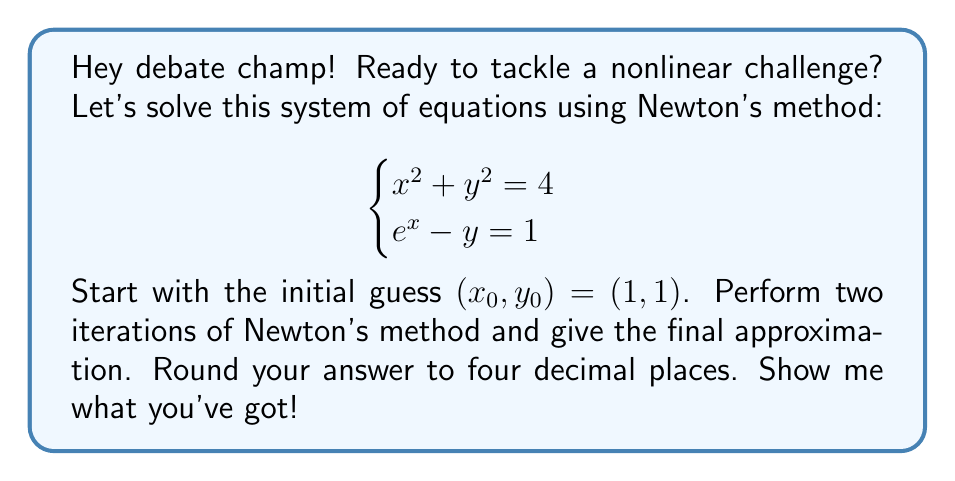Give your solution to this math problem. Alright, let's break this down step-by-step:

1) First, we need to define our functions:
   $f_1(x,y) = x^2 + y^2 - 4$
   $f_2(x,y) = e^x - y - 1$

2) Now, we need to calculate the Jacobian matrix:
   $$J = \begin{bmatrix}
   \frac{\partial f_1}{\partial x} & \frac{\partial f_1}{\partial y} \\
   \frac{\partial f_2}{\partial x} & \frac{\partial f_2}{\partial y}
   \end{bmatrix} = \begin{bmatrix}
   2x & 2y \\
   e^x & -1
   \end{bmatrix}$$

3) Newton's method for systems of equations is given by:
   $$\begin{bmatrix} x_{n+1} \\ y_{n+1} \end{bmatrix} = \begin{bmatrix} x_n \\ y_n \end{bmatrix} - J^{-1}(x_n, y_n) \begin{bmatrix} f_1(x_n, y_n) \\ f_2(x_n, y_n) \end{bmatrix}$$

4) For the first iteration $(n=0)$:
   $x_0 = 1, y_0 = 1$
   
   $J(1,1) = \begin{bmatrix} 2 & 2 \\ e & -1 \end{bmatrix}$
   
   $J^{-1}(1,1) = \frac{1}{-2-2e} \begin{bmatrix} -1 & -2 \\ -e & -2 \end{bmatrix}$
   
   $\begin{bmatrix} f_1(1,1) \\ f_2(1,1) \end{bmatrix} = \begin{bmatrix} -2 \\ e-2 \end{bmatrix}$

   $$\begin{bmatrix} x_1 \\ y_1 \end{bmatrix} = \begin{bmatrix} 1 \\ 1 \end{bmatrix} - \frac{1}{-2-2e} \begin{bmatrix} -1 & -2 \\ -e & -2 \end{bmatrix} \begin{bmatrix} -2 \\ e-2 \end{bmatrix}$$

   Calculating this gives us: $x_1 \approx 1.5652, y_1 \approx 1.5652$

5) For the second iteration $(n=1)$:
   We repeat the process with $x_1$ and $y_1$, calculating $J(x_1,y_1)$, its inverse, and $f_1(x_1,y_1)$ and $f_2(x_1,y_1)$.

   After performing these calculations, we get:
   $x_2 \approx 1.5431, y_2 \approx 1.5431$

6) Rounding to four decimal places, our final approximation is (1.5431, 1.5431).
Answer: (1.5431, 1.5431) 